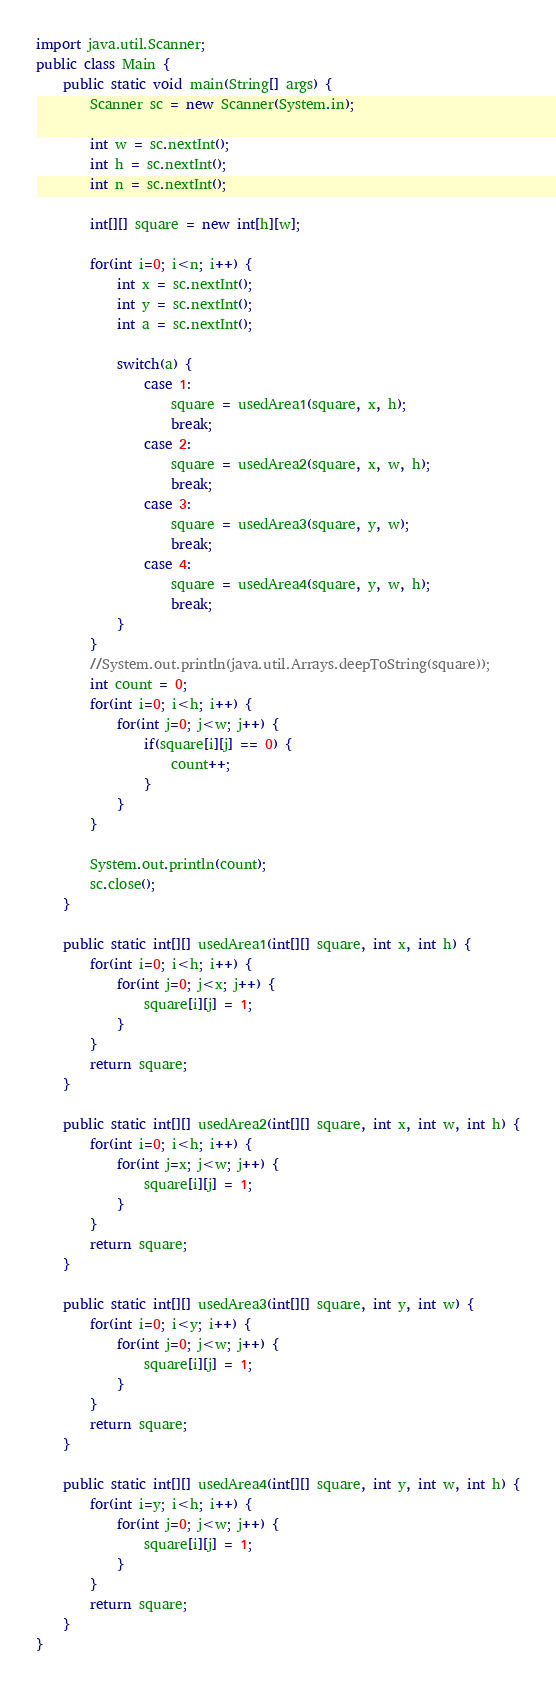Convert code to text. <code><loc_0><loc_0><loc_500><loc_500><_Java_>import java.util.Scanner;
public class Main {
    public static void main(String[] args) {
        Scanner sc = new Scanner(System.in);

        int w = sc.nextInt();
        int h = sc.nextInt();
        int n = sc.nextInt();

        int[][] square = new int[h][w];

        for(int i=0; i<n; i++) {
            int x = sc.nextInt();
            int y = sc.nextInt();
            int a = sc.nextInt();

            switch(a) {
                case 1:
                    square = usedArea1(square, x, h);
                    break;
                case 2:
                    square = usedArea2(square, x, w, h);
                    break;
                case 3:
                    square = usedArea3(square, y, w);
                    break;
                case 4:
                    square = usedArea4(square, y, w, h);
                    break;
            }
        }
        //System.out.println(java.util.Arrays.deepToString(square));
        int count = 0;
        for(int i=0; i<h; i++) {
            for(int j=0; j<w; j++) {
                if(square[i][j] == 0) {
                    count++;
                }
            }
        }

        System.out.println(count);
        sc.close();
    }

    public static int[][] usedArea1(int[][] square, int x, int h) {
        for(int i=0; i<h; i++) {
            for(int j=0; j<x; j++) {
                square[i][j] = 1;
            }
        }
        return square;
    }

    public static int[][] usedArea2(int[][] square, int x, int w, int h) {
        for(int i=0; i<h; i++) {
            for(int j=x; j<w; j++) {
                square[i][j] = 1;
            }
        }
        return square;
    }

    public static int[][] usedArea3(int[][] square, int y, int w) {
        for(int i=0; i<y; i++) {
            for(int j=0; j<w; j++) {
                square[i][j] = 1;
            }
        }
        return square;
    }

    public static int[][] usedArea4(int[][] square, int y, int w, int h) {
        for(int i=y; i<h; i++) {
            for(int j=0; j<w; j++) {
                square[i][j] = 1;
            }
        }
        return square;
    }
}
</code> 